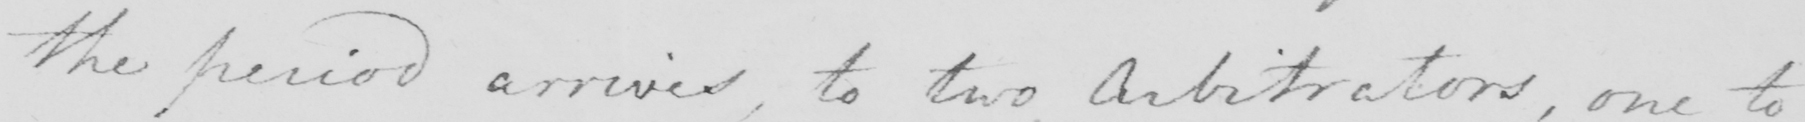What text is written in this handwritten line? the period arrives , to two Arbitrators , one to 